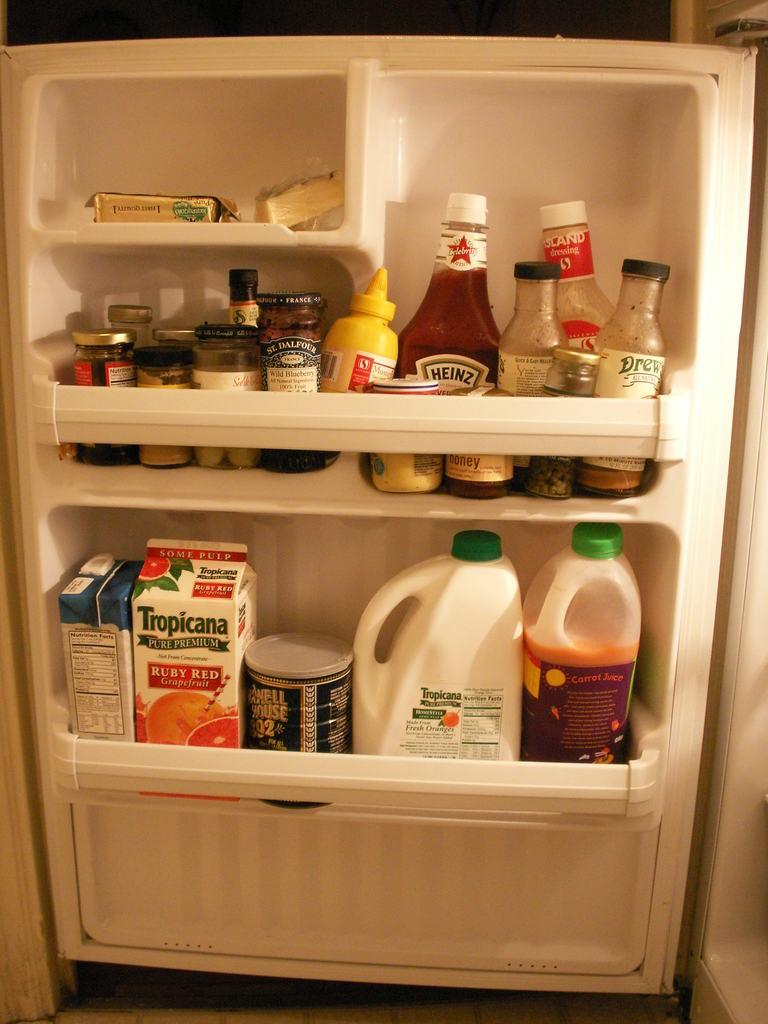Provide a one-sentence caption for the provided image. A container of Ruby Red Grapefruit juice is in the door of the refrigerator. 